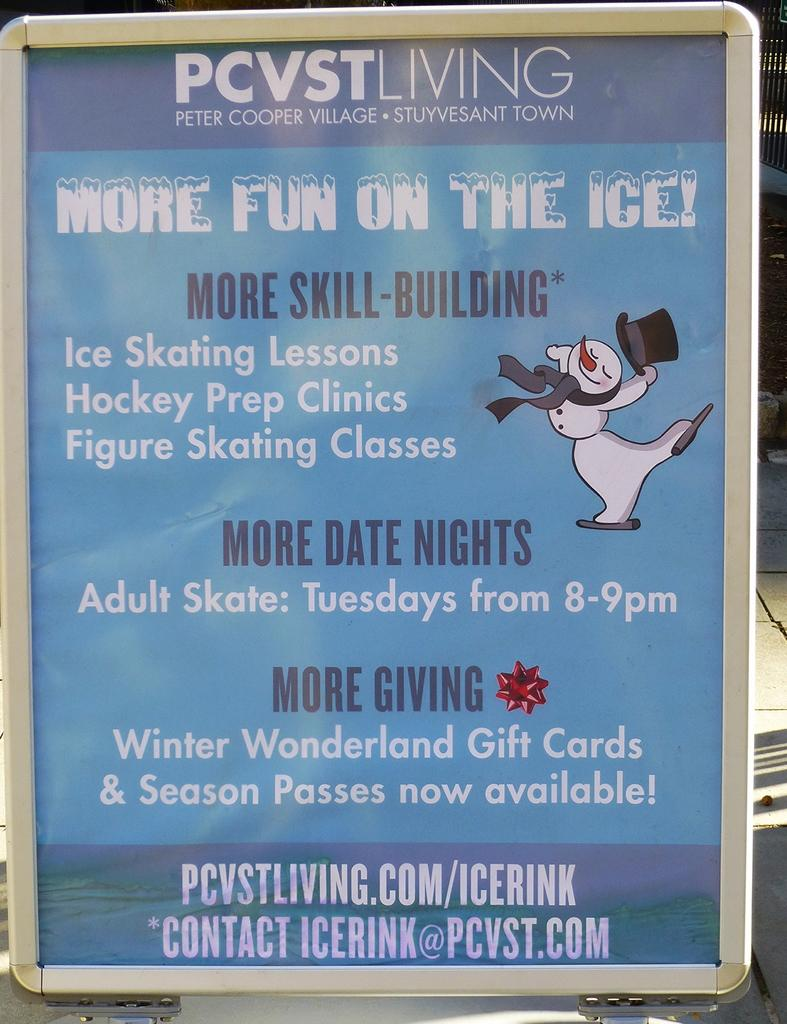<image>
Write a terse but informative summary of the picture. An advertisement for ice skating lessons on Tuesday nights 